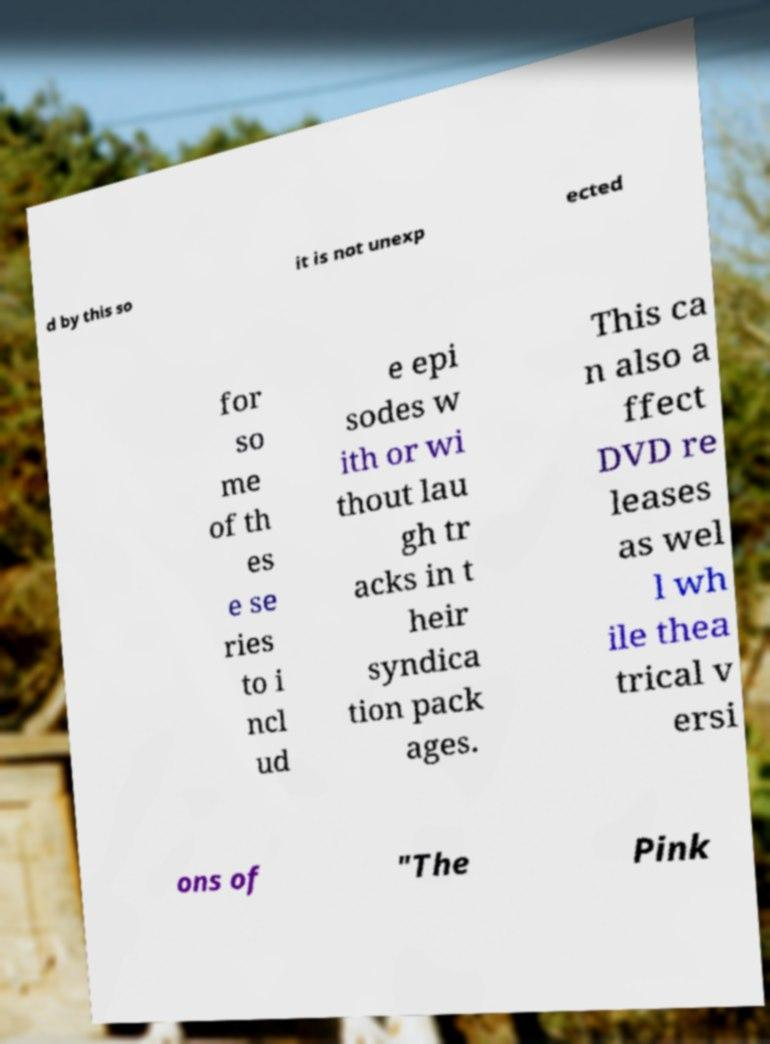Could you assist in decoding the text presented in this image and type it out clearly? d by this so it is not unexp ected for so me of th es e se ries to i ncl ud e epi sodes w ith or wi thout lau gh tr acks in t heir syndica tion pack ages. This ca n also a ffect DVD re leases as wel l wh ile thea trical v ersi ons of "The Pink 